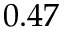Convert formula to latex. <formula><loc_0><loc_0><loc_500><loc_500>0 . 4 7</formula> 